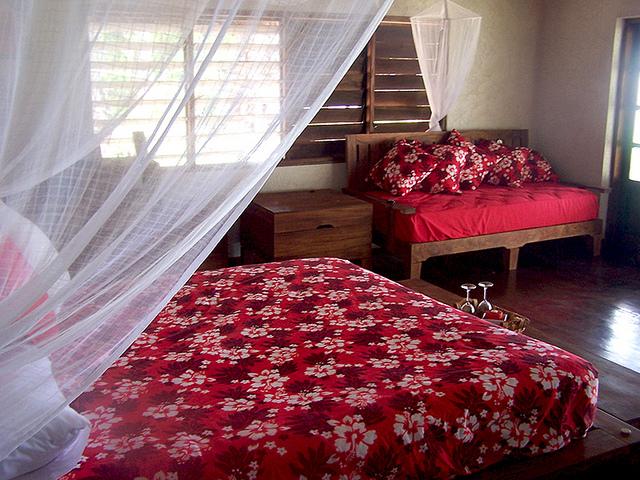Is this a relaxing environment?
Concise answer only. Yes. What are the blinds on the windows made out of?
Give a very brief answer. Wood. Does this room look carefully designed?
Concise answer only. Yes. 